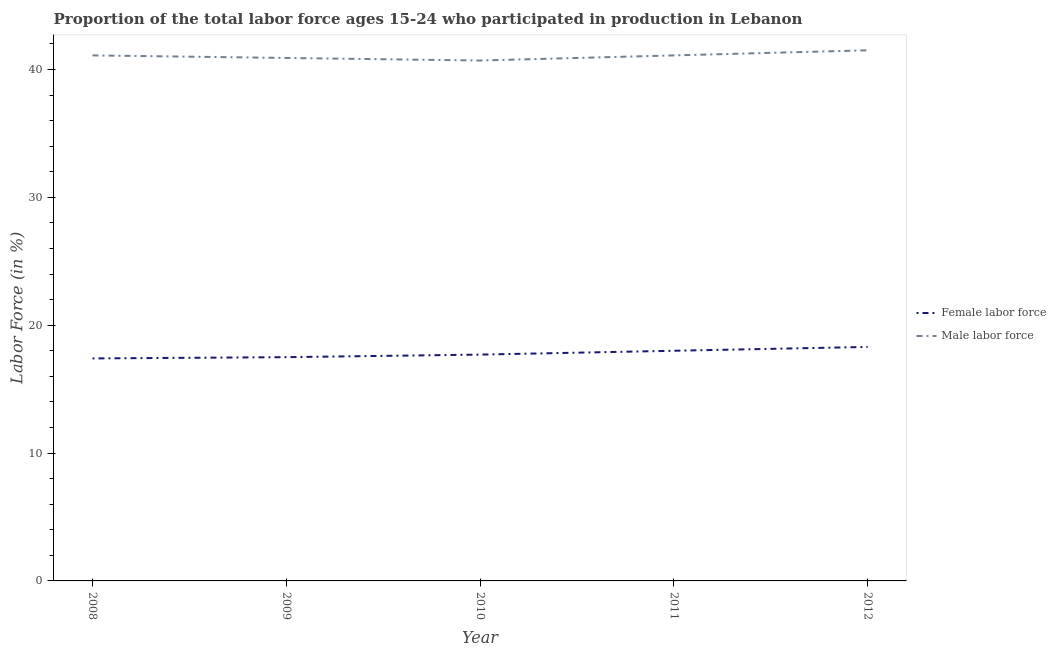Does the line corresponding to percentage of male labour force intersect with the line corresponding to percentage of female labor force?
Provide a short and direct response. No. Is the number of lines equal to the number of legend labels?
Ensure brevity in your answer.  Yes. What is the percentage of male labour force in 2009?
Offer a terse response. 40.9. Across all years, what is the maximum percentage of male labour force?
Give a very brief answer. 41.5. Across all years, what is the minimum percentage of male labour force?
Your answer should be very brief. 40.7. In which year was the percentage of female labor force minimum?
Provide a succinct answer. 2008. What is the total percentage of male labour force in the graph?
Keep it short and to the point. 205.3. What is the difference between the percentage of female labor force in 2009 and that in 2012?
Offer a very short reply. -0.8. What is the difference between the percentage of male labour force in 2009 and the percentage of female labor force in 2008?
Your response must be concise. 23.5. What is the average percentage of male labour force per year?
Keep it short and to the point. 41.06. In the year 2012, what is the difference between the percentage of male labour force and percentage of female labor force?
Your answer should be compact. 23.2. What is the ratio of the percentage of female labor force in 2008 to that in 2009?
Give a very brief answer. 0.99. Is the percentage of female labor force in 2008 less than that in 2011?
Your answer should be compact. Yes. What is the difference between the highest and the second highest percentage of female labor force?
Your answer should be compact. 0.3. What is the difference between the highest and the lowest percentage of male labour force?
Your answer should be compact. 0.8. Is the percentage of female labor force strictly greater than the percentage of male labour force over the years?
Offer a terse response. No. How many lines are there?
Provide a succinct answer. 2. How many years are there in the graph?
Your answer should be very brief. 5. Does the graph contain any zero values?
Ensure brevity in your answer.  No. Where does the legend appear in the graph?
Give a very brief answer. Center right. What is the title of the graph?
Keep it short and to the point. Proportion of the total labor force ages 15-24 who participated in production in Lebanon. Does "Highest 20% of population" appear as one of the legend labels in the graph?
Provide a succinct answer. No. What is the Labor Force (in %) of Female labor force in 2008?
Your response must be concise. 17.4. What is the Labor Force (in %) in Male labor force in 2008?
Offer a terse response. 41.1. What is the Labor Force (in %) of Female labor force in 2009?
Offer a very short reply. 17.5. What is the Labor Force (in %) in Male labor force in 2009?
Make the answer very short. 40.9. What is the Labor Force (in %) of Female labor force in 2010?
Ensure brevity in your answer.  17.7. What is the Labor Force (in %) of Male labor force in 2010?
Ensure brevity in your answer.  40.7. What is the Labor Force (in %) of Male labor force in 2011?
Offer a very short reply. 41.1. What is the Labor Force (in %) of Female labor force in 2012?
Offer a very short reply. 18.3. What is the Labor Force (in %) of Male labor force in 2012?
Make the answer very short. 41.5. Across all years, what is the maximum Labor Force (in %) in Female labor force?
Ensure brevity in your answer.  18.3. Across all years, what is the maximum Labor Force (in %) in Male labor force?
Give a very brief answer. 41.5. Across all years, what is the minimum Labor Force (in %) of Female labor force?
Give a very brief answer. 17.4. Across all years, what is the minimum Labor Force (in %) in Male labor force?
Give a very brief answer. 40.7. What is the total Labor Force (in %) in Female labor force in the graph?
Give a very brief answer. 88.9. What is the total Labor Force (in %) of Male labor force in the graph?
Your response must be concise. 205.3. What is the difference between the Labor Force (in %) in Female labor force in 2008 and that in 2011?
Offer a terse response. -0.6. What is the difference between the Labor Force (in %) in Female labor force in 2009 and that in 2010?
Offer a terse response. -0.2. What is the difference between the Labor Force (in %) in Male labor force in 2009 and that in 2010?
Provide a succinct answer. 0.2. What is the difference between the Labor Force (in %) in Male labor force in 2009 and that in 2012?
Ensure brevity in your answer.  -0.6. What is the difference between the Labor Force (in %) of Male labor force in 2010 and that in 2011?
Offer a terse response. -0.4. What is the difference between the Labor Force (in %) of Male labor force in 2011 and that in 2012?
Your answer should be very brief. -0.4. What is the difference between the Labor Force (in %) in Female labor force in 2008 and the Labor Force (in %) in Male labor force in 2009?
Offer a terse response. -23.5. What is the difference between the Labor Force (in %) in Female labor force in 2008 and the Labor Force (in %) in Male labor force in 2010?
Provide a succinct answer. -23.3. What is the difference between the Labor Force (in %) of Female labor force in 2008 and the Labor Force (in %) of Male labor force in 2011?
Offer a very short reply. -23.7. What is the difference between the Labor Force (in %) in Female labor force in 2008 and the Labor Force (in %) in Male labor force in 2012?
Your answer should be compact. -24.1. What is the difference between the Labor Force (in %) of Female labor force in 2009 and the Labor Force (in %) of Male labor force in 2010?
Offer a terse response. -23.2. What is the difference between the Labor Force (in %) in Female labor force in 2009 and the Labor Force (in %) in Male labor force in 2011?
Offer a very short reply. -23.6. What is the difference between the Labor Force (in %) in Female labor force in 2010 and the Labor Force (in %) in Male labor force in 2011?
Give a very brief answer. -23.4. What is the difference between the Labor Force (in %) in Female labor force in 2010 and the Labor Force (in %) in Male labor force in 2012?
Offer a terse response. -23.8. What is the difference between the Labor Force (in %) of Female labor force in 2011 and the Labor Force (in %) of Male labor force in 2012?
Ensure brevity in your answer.  -23.5. What is the average Labor Force (in %) of Female labor force per year?
Provide a short and direct response. 17.78. What is the average Labor Force (in %) in Male labor force per year?
Make the answer very short. 41.06. In the year 2008, what is the difference between the Labor Force (in %) in Female labor force and Labor Force (in %) in Male labor force?
Give a very brief answer. -23.7. In the year 2009, what is the difference between the Labor Force (in %) in Female labor force and Labor Force (in %) in Male labor force?
Provide a succinct answer. -23.4. In the year 2010, what is the difference between the Labor Force (in %) in Female labor force and Labor Force (in %) in Male labor force?
Your answer should be compact. -23. In the year 2011, what is the difference between the Labor Force (in %) of Female labor force and Labor Force (in %) of Male labor force?
Give a very brief answer. -23.1. In the year 2012, what is the difference between the Labor Force (in %) in Female labor force and Labor Force (in %) in Male labor force?
Give a very brief answer. -23.2. What is the ratio of the Labor Force (in %) in Female labor force in 2008 to that in 2010?
Offer a terse response. 0.98. What is the ratio of the Labor Force (in %) of Male labor force in 2008 to that in 2010?
Keep it short and to the point. 1.01. What is the ratio of the Labor Force (in %) of Female labor force in 2008 to that in 2011?
Offer a terse response. 0.97. What is the ratio of the Labor Force (in %) of Female labor force in 2008 to that in 2012?
Offer a terse response. 0.95. What is the ratio of the Labor Force (in %) of Male labor force in 2008 to that in 2012?
Keep it short and to the point. 0.99. What is the ratio of the Labor Force (in %) in Female labor force in 2009 to that in 2010?
Ensure brevity in your answer.  0.99. What is the ratio of the Labor Force (in %) of Female labor force in 2009 to that in 2011?
Ensure brevity in your answer.  0.97. What is the ratio of the Labor Force (in %) of Female labor force in 2009 to that in 2012?
Give a very brief answer. 0.96. What is the ratio of the Labor Force (in %) in Male labor force in 2009 to that in 2012?
Make the answer very short. 0.99. What is the ratio of the Labor Force (in %) in Female labor force in 2010 to that in 2011?
Your response must be concise. 0.98. What is the ratio of the Labor Force (in %) of Male labor force in 2010 to that in 2011?
Make the answer very short. 0.99. What is the ratio of the Labor Force (in %) of Female labor force in 2010 to that in 2012?
Your answer should be compact. 0.97. What is the ratio of the Labor Force (in %) of Male labor force in 2010 to that in 2012?
Offer a terse response. 0.98. What is the ratio of the Labor Force (in %) in Female labor force in 2011 to that in 2012?
Provide a succinct answer. 0.98. What is the ratio of the Labor Force (in %) of Male labor force in 2011 to that in 2012?
Offer a terse response. 0.99. What is the difference between the highest and the second highest Labor Force (in %) of Male labor force?
Your answer should be very brief. 0.4. What is the difference between the highest and the lowest Labor Force (in %) of Male labor force?
Make the answer very short. 0.8. 